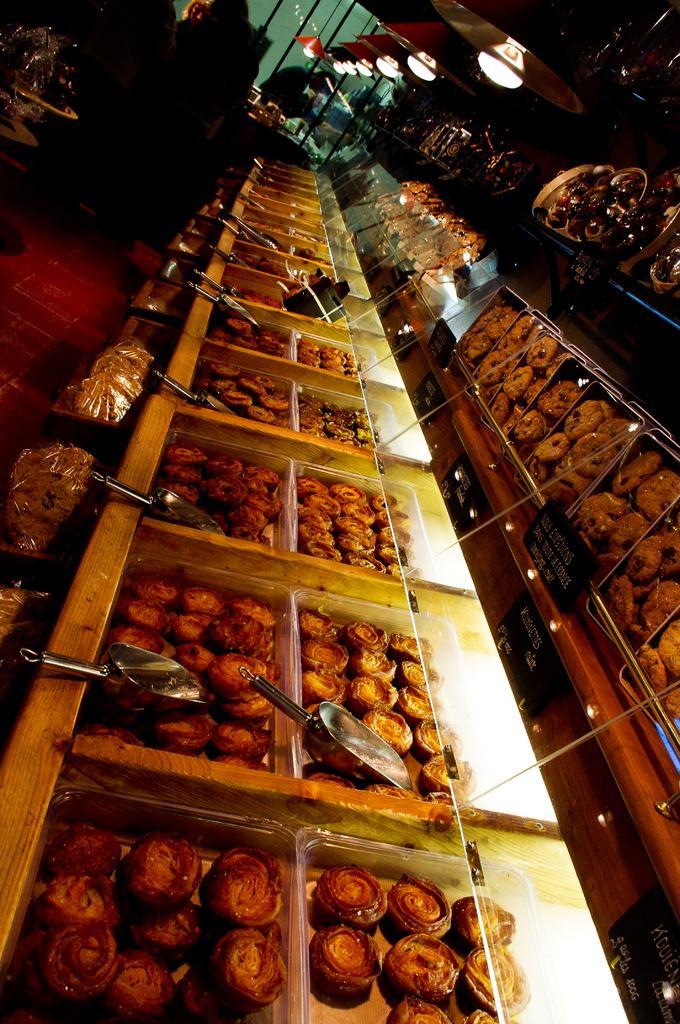Describe this image in one or two sentences. In this image we some food items which are arranged in boxes and top of the image there are some lights. 